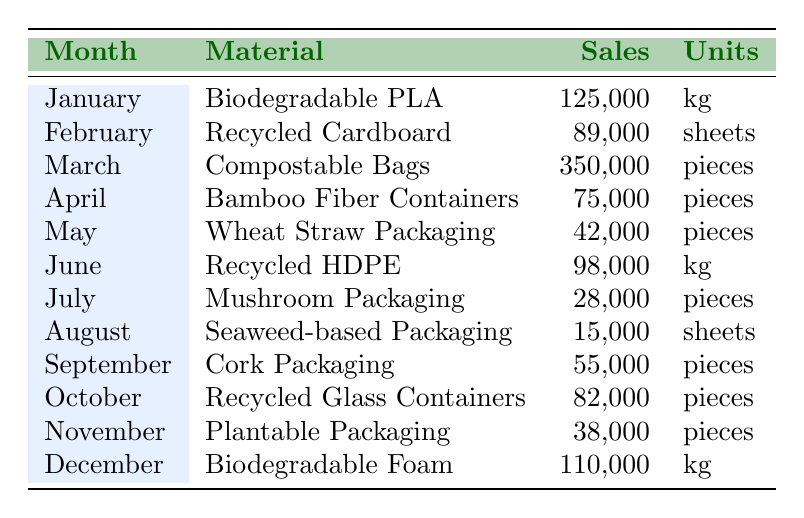What was the highest selling eco-friendly packaging material in March 2023? The table shows that in March 2023, the highest selling material was Compostable Bags with sales of 350,000 pieces.
Answer: Compostable Bags Which month had the lowest sales for eco-friendly packaging materials? Looking at the sales figures in the table, August 2023 had the lowest sales with 15,000 sheets for Seaweed-based Packaging.
Answer: August 2023 What is the total sales of Biodegradable materials in January and December 2023? The sales for Biodegradable materials are 125,000 in January for Biodegradable PLA and 110,000 in December for Biodegradable Foam. The total is 125,000 + 110,000 = 235,000.
Answer: 235,000 Did any month have sales exceeding 300,000 pieces? The table shows that no month had sales exceeding 300,000 pieces, as the highest sales recorded is 350,000 pieces in March 2023, meeting criteria but not exceeding.
Answer: Yes Which material had higher sales, Recycled Cardboard or Cork Packaging? Recycled Cardboard had sales of 89,000 sheets in February 2023, while Cork Packaging had sales of 55,000 pieces in September 2023. Since 89,000 is higher than 55,000, Recycled Cardboard had higher sales.
Answer: Recycled Cardboard What is the average monthly sales for the materials between January and June 2023? To find the average, we sum all sales from January to June: 125,000 + 89,000 + 350,000 + 75,000 + 42,000 + 98,000 = 779,000. There are 6 months, so average is 779,000/6 ≈ 129,833.33.
Answer: 129,833.33 How much more did Compostable Bags sell compared to Bamboo Fiber Containers? Compostable Bags sold 350,000 pieces, and Bamboo Fiber Containers sold 75,000 pieces. The difference is 350,000 - 75,000 = 275,000.
Answer: 275,000 What percentage of the total sales in December were from Biodegradable Foam? In December, Biodegradable Foam accounted for 110,000 sales. The total sales for all months is 1,030,000 (sum of all monthly sales). To find the percentage: (110,000 / 1,030,000) * 100% ≈ 10.68%.
Answer: 10.68% Which month showed a decrease in sales compared to the previous month? By comparing the sales month over month, July shows a decrease with 28,000 pieces sold compared to 98,000 in June.
Answer: July How many pieces of Seaweed-based Packaging were sold in August 2023? The table indicates that 15,000 sheets of Seaweed-based Packaging were sold in August 2023.
Answer: 15,000 sheets 